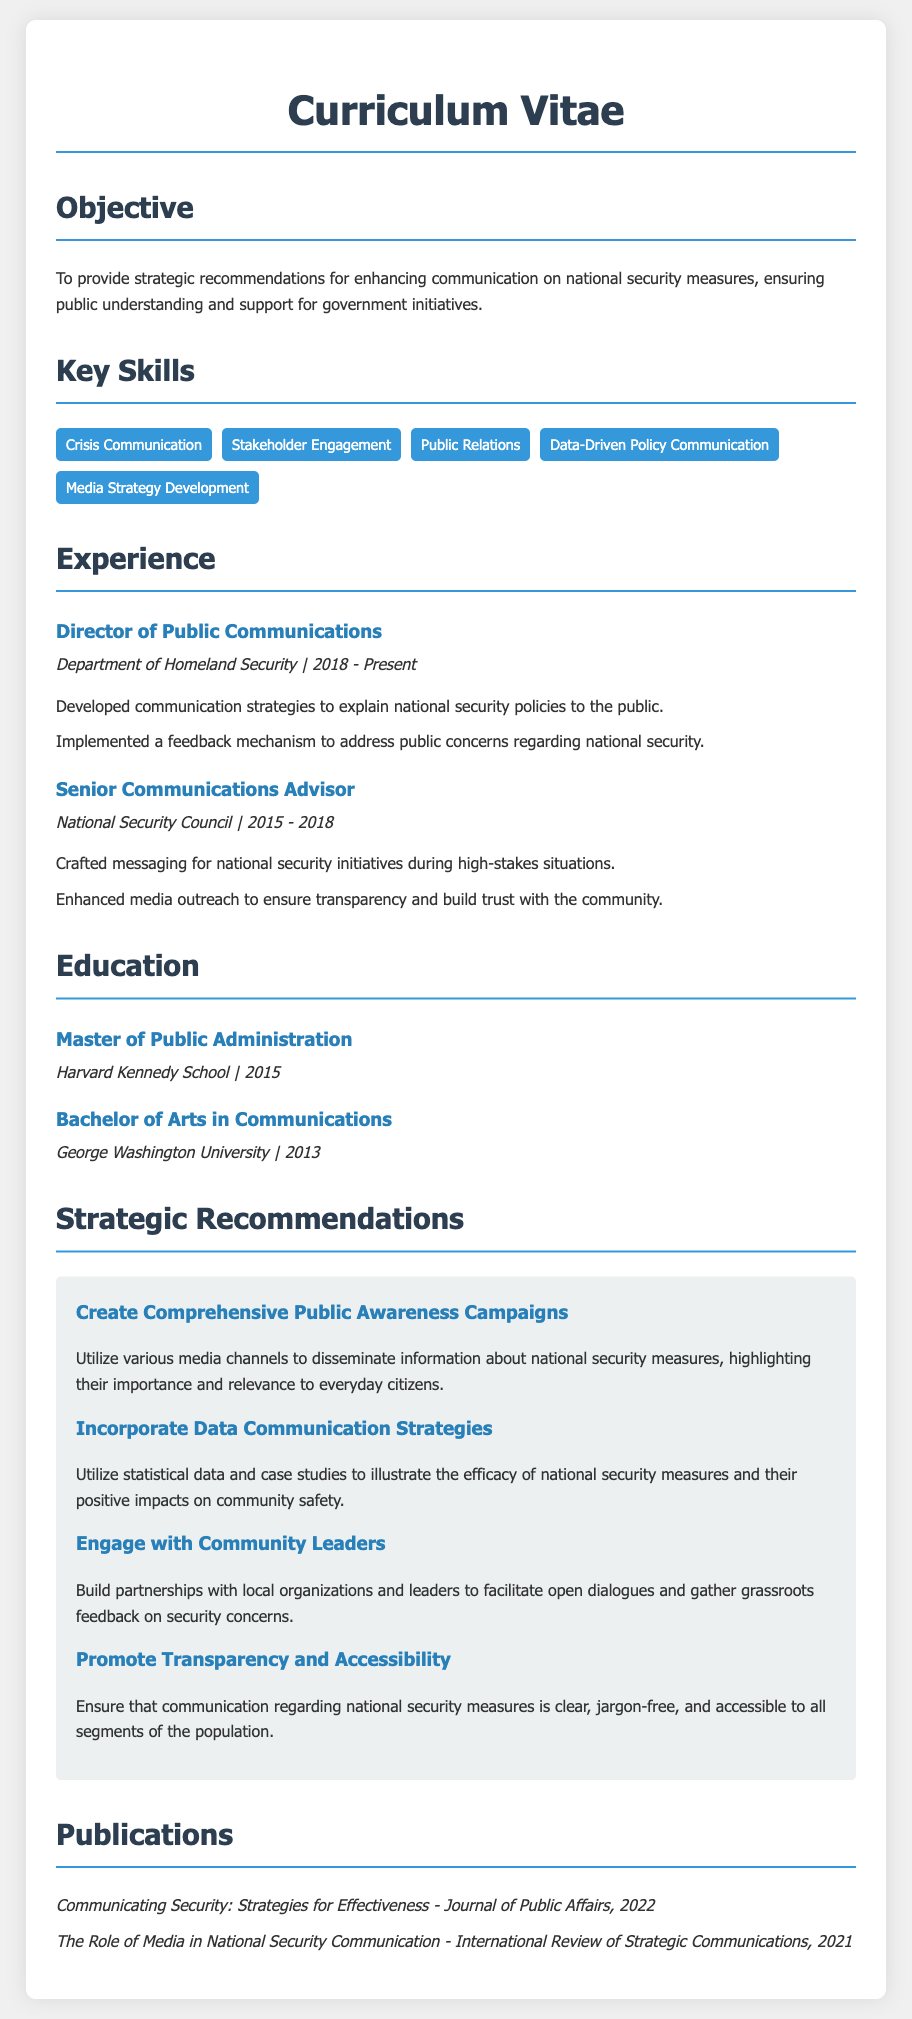What is the title of the document? The title of the document is found in the header section, indicating the subject matter of the document.
Answer: Curriculum Vitae - National Security Communication Expert Who is the current Director of Public Communications? This information is located in the experience section where the person's current role is listed.
Answer: Director of Public Communications What year did the education in Master of Public Administration take place? The education section specifies the year the degree was completed, providing a clear indicator of the timeframe.
Answer: 2015 How many years did the individual work at the National Security Council? By subtracting the start year from the end year in the experience section, one can determine the duration of employment.
Answer: 3 years What is one of the key skills listed in the document? The document contains a skills section that enumerates various competencies relevant to national security communication.
Answer: Crisis Communication What is the first strategic recommendation mentioned? The strategic recommendations section lists several approaches, starting with the first recommendation outlined in the text.
Answer: Create Comprehensive Public Awareness Campaigns In which journal was the publication "Communicating Security: Strategies for Effectiveness" published? This information is found in the publications section that details where each work was published.
Answer: Journal of Public Affairs How many organizations did the individual represent in the experience section? A count of the distinct roles mentioned in the experience section will provide the number of organizations.
Answer: 2 organizations What type of degree did the person earn at George Washington University? The education section specifies the nature of the degree achieved, indicating the area of study.
Answer: Bachelor of Arts in Communications 